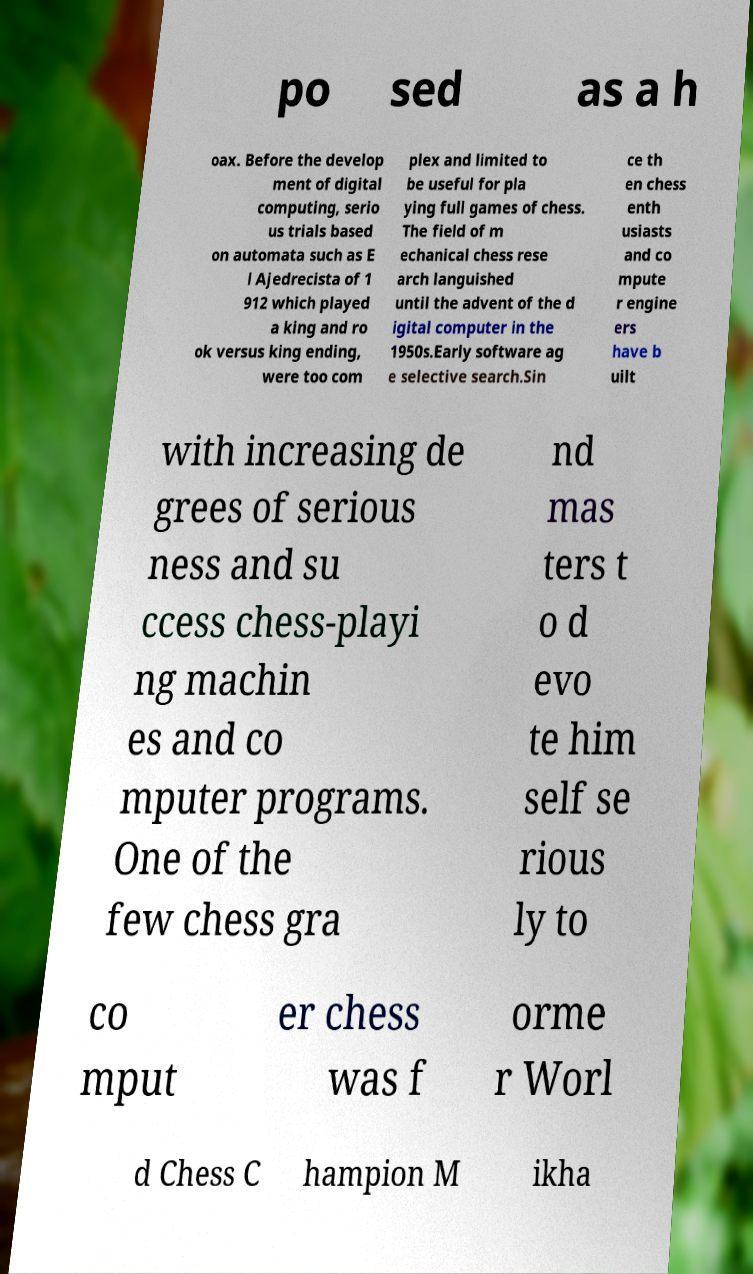Please identify and transcribe the text found in this image. po sed as a h oax. Before the develop ment of digital computing, serio us trials based on automata such as E l Ajedrecista of 1 912 which played a king and ro ok versus king ending, were too com plex and limited to be useful for pla ying full games of chess. The field of m echanical chess rese arch languished until the advent of the d igital computer in the 1950s.Early software ag e selective search.Sin ce th en chess enth usiasts and co mpute r engine ers have b uilt with increasing de grees of serious ness and su ccess chess-playi ng machin es and co mputer programs. One of the few chess gra nd mas ters t o d evo te him self se rious ly to co mput er chess was f orme r Worl d Chess C hampion M ikha 